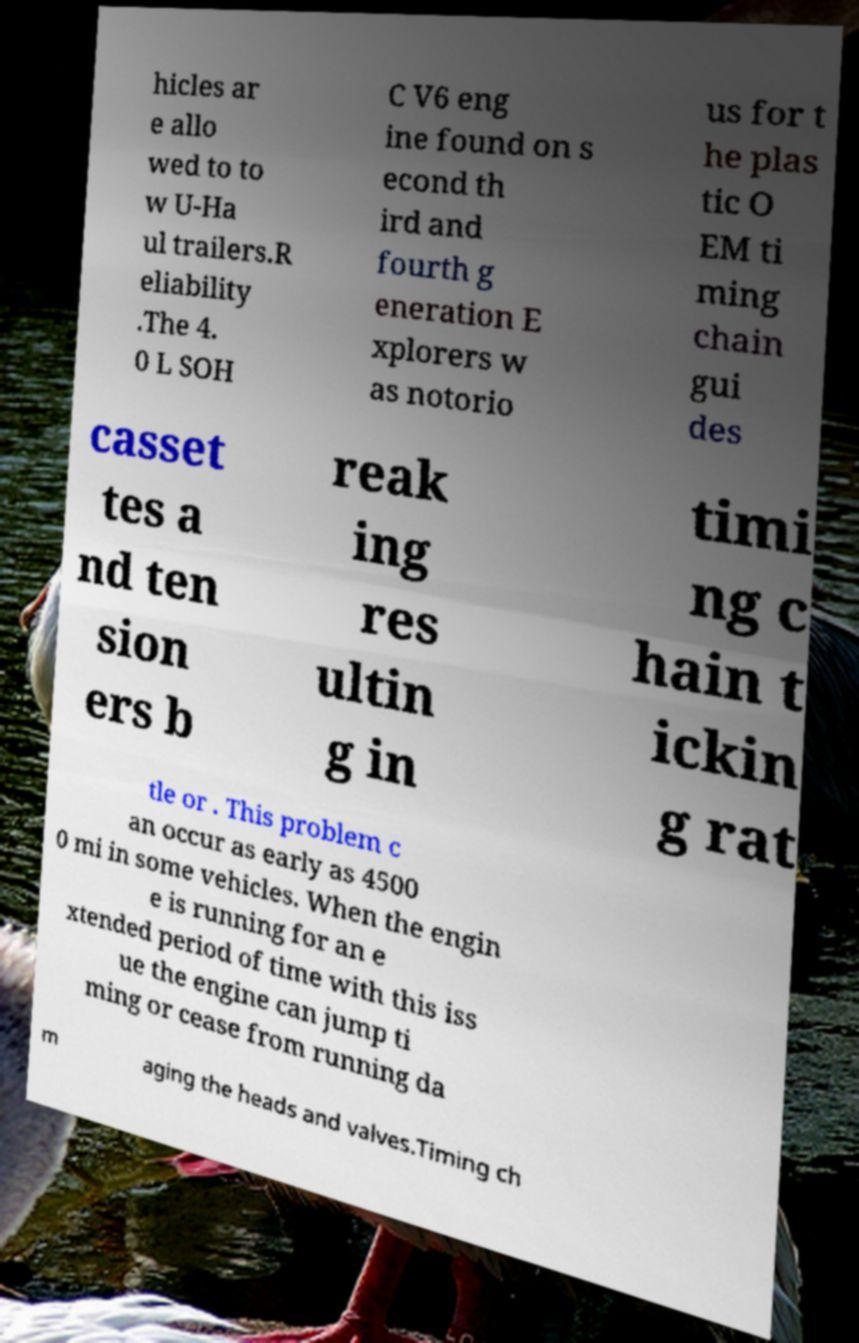Can you accurately transcribe the text from the provided image for me? hicles ar e allo wed to to w U-Ha ul trailers.R eliability .The 4. 0 L SOH C V6 eng ine found on s econd th ird and fourth g eneration E xplorers w as notorio us for t he plas tic O EM ti ming chain gui des casset tes a nd ten sion ers b reak ing res ultin g in timi ng c hain t ickin g rat tle or . This problem c an occur as early as 4500 0 mi in some vehicles. When the engin e is running for an e xtended period of time with this iss ue the engine can jump ti ming or cease from running da m aging the heads and valves.Timing ch 